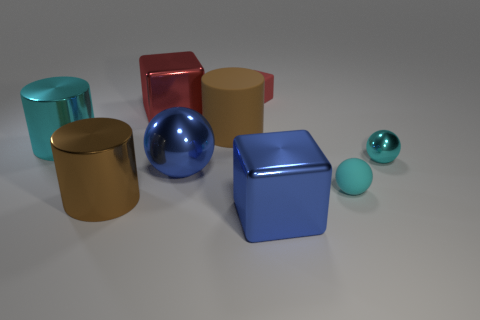Subtract all blocks. How many objects are left? 6 Add 5 big blue shiny things. How many big blue shiny things exist? 7 Subtract 0 yellow cubes. How many objects are left? 9 Subtract all large brown metallic things. Subtract all big cyan cylinders. How many objects are left? 7 Add 7 large blue spheres. How many large blue spheres are left? 8 